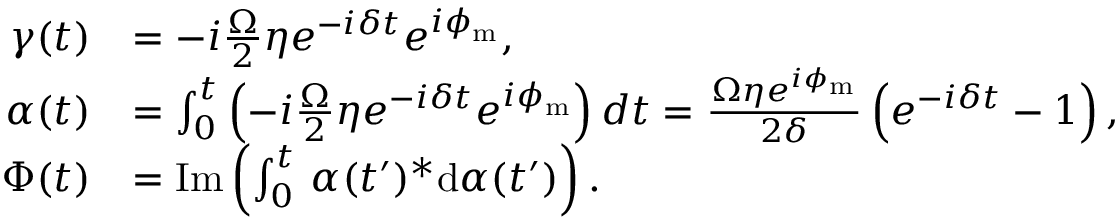<formula> <loc_0><loc_0><loc_500><loc_500>\begin{array} { r l } { \gamma ( t ) } & { = - i \frac { \Omega } { 2 } \eta e ^ { - i \delta t } e ^ { i \phi _ { m } } , } \\ { \alpha ( t ) } & { = \int _ { 0 } ^ { t } \left ( - i \frac { \Omega } { 2 } \eta e ^ { - i \delta t } e ^ { i \phi _ { m } } \right ) d t = \frac { \Omega \eta e ^ { i \phi _ { m } } } { 2 \delta } \left ( e ^ { - i \delta t } - 1 \right ) , } \\ { \Phi ( t ) } & { = I m \left ( \int _ { 0 } ^ { t } \, \alpha ( t ^ { \prime } ) ^ { * } d \alpha ( t ^ { \prime } ) \right ) . } \end{array}</formula> 